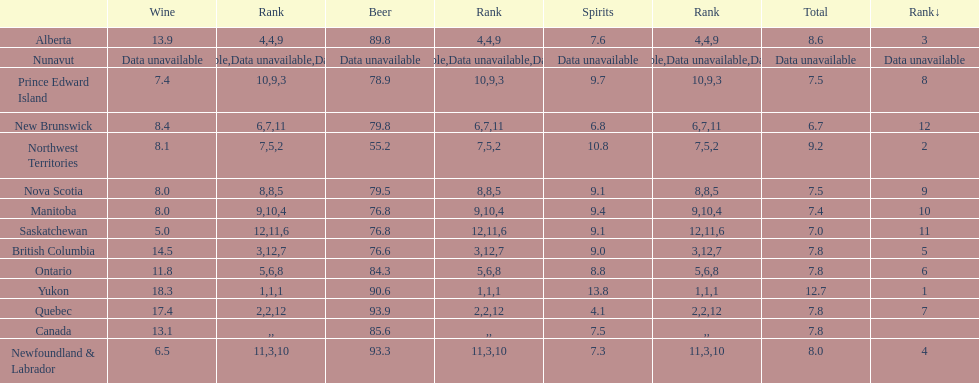Parse the full table. {'header': ['', 'Wine', 'Rank', 'Beer', 'Rank', 'Spirits', 'Rank', 'Total', 'Rank↓'], 'rows': [['Alberta', '13.9', '4', '89.8', '4', '7.6', '9', '8.6', '3'], ['Nunavut', 'Data unavailable', 'Data unavailable', 'Data unavailable', 'Data unavailable', 'Data unavailable', 'Data unavailable', 'Data unavailable', 'Data unavailable'], ['Prince Edward Island', '7.4', '10', '78.9', '9', '9.7', '3', '7.5', '8'], ['New Brunswick', '8.4', '6', '79.8', '7', '6.8', '11', '6.7', '12'], ['Northwest Territories', '8.1', '7', '55.2', '5', '10.8', '2', '9.2', '2'], ['Nova Scotia', '8.0', '8', '79.5', '8', '9.1', '5', '7.5', '9'], ['Manitoba', '8.0', '9', '76.8', '10', '9.4', '4', '7.4', '10'], ['Saskatchewan', '5.0', '12', '76.8', '11', '9.1', '6', '7.0', '11'], ['British Columbia', '14.5', '3', '76.6', '12', '9.0', '7', '7.8', '5'], ['Ontario', '11.8', '5', '84.3', '6', '8.8', '8', '7.8', '6'], ['Yukon', '18.3', '1', '90.6', '1', '13.8', '1', '12.7', '1'], ['Quebec', '17.4', '2', '93.9', '2', '4.1', '12', '7.8', '7'], ['Canada', '13.1', '', '85.6', '', '7.5', '', '7.8', ''], ['Newfoundland & Labrador', '6.5', '11', '93.3', '3', '7.3', '10', '8.0', '4']]} Which province is the top consumer of wine? Yukon. 